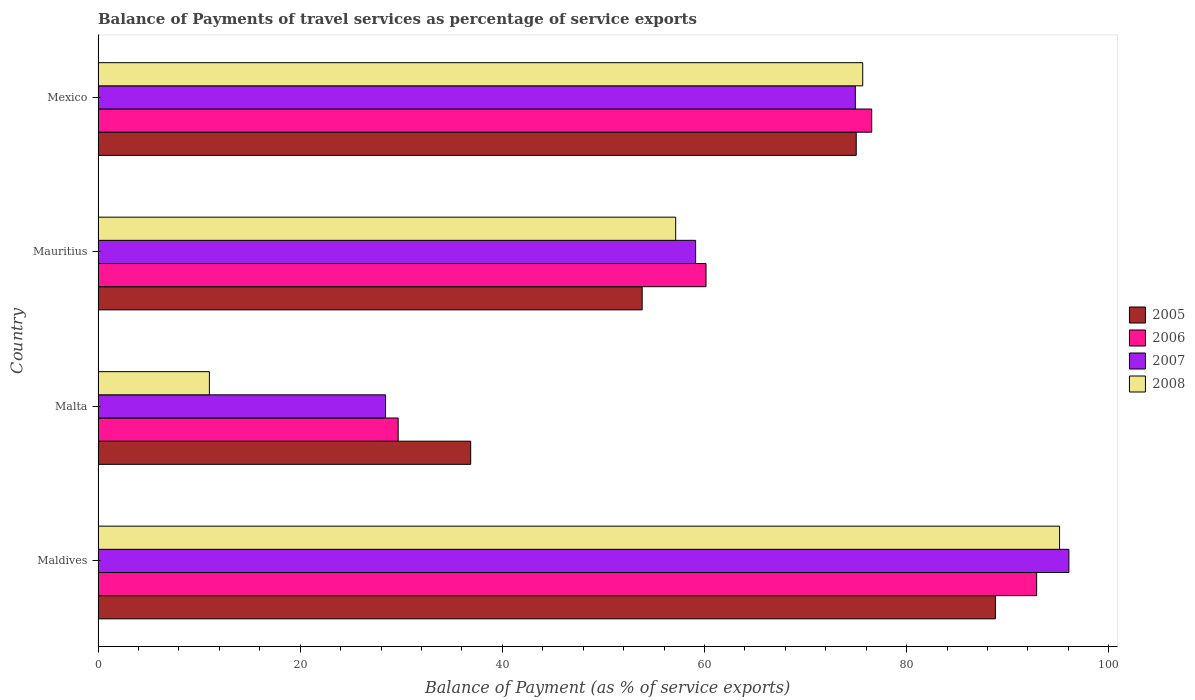How many different coloured bars are there?
Provide a succinct answer. 4. How many groups of bars are there?
Give a very brief answer. 4. Are the number of bars on each tick of the Y-axis equal?
Offer a terse response. Yes. How many bars are there on the 2nd tick from the bottom?
Offer a very short reply. 4. What is the label of the 4th group of bars from the top?
Offer a very short reply. Maldives. In how many cases, is the number of bars for a given country not equal to the number of legend labels?
Offer a very short reply. 0. What is the balance of payments of travel services in 2005 in Malta?
Make the answer very short. 36.87. Across all countries, what is the maximum balance of payments of travel services in 2007?
Offer a terse response. 96.05. Across all countries, what is the minimum balance of payments of travel services in 2005?
Offer a very short reply. 36.87. In which country was the balance of payments of travel services in 2005 maximum?
Ensure brevity in your answer.  Maldives. In which country was the balance of payments of travel services in 2007 minimum?
Make the answer very short. Malta. What is the total balance of payments of travel services in 2006 in the graph?
Your answer should be compact. 259.24. What is the difference between the balance of payments of travel services in 2006 in Maldives and that in Mauritius?
Ensure brevity in your answer.  32.71. What is the difference between the balance of payments of travel services in 2008 in Mauritius and the balance of payments of travel services in 2006 in Malta?
Give a very brief answer. 27.46. What is the average balance of payments of travel services in 2008 per country?
Offer a terse response. 59.73. What is the difference between the balance of payments of travel services in 2007 and balance of payments of travel services in 2005 in Mauritius?
Ensure brevity in your answer.  5.29. What is the ratio of the balance of payments of travel services in 2008 in Malta to that in Mauritius?
Keep it short and to the point. 0.19. Is the balance of payments of travel services in 2007 in Maldives less than that in Mauritius?
Provide a succinct answer. No. What is the difference between the highest and the second highest balance of payments of travel services in 2005?
Your response must be concise. 13.77. What is the difference between the highest and the lowest balance of payments of travel services in 2005?
Ensure brevity in your answer.  51.91. In how many countries, is the balance of payments of travel services in 2007 greater than the average balance of payments of travel services in 2007 taken over all countries?
Provide a short and direct response. 2. Is the sum of the balance of payments of travel services in 2006 in Malta and Mexico greater than the maximum balance of payments of travel services in 2005 across all countries?
Offer a terse response. Yes. Is it the case that in every country, the sum of the balance of payments of travel services in 2006 and balance of payments of travel services in 2005 is greater than the sum of balance of payments of travel services in 2007 and balance of payments of travel services in 2008?
Provide a short and direct response. No. What does the 3rd bar from the top in Malta represents?
Offer a very short reply. 2006. What does the 4th bar from the bottom in Mauritius represents?
Give a very brief answer. 2008. Is it the case that in every country, the sum of the balance of payments of travel services in 2007 and balance of payments of travel services in 2008 is greater than the balance of payments of travel services in 2005?
Provide a succinct answer. Yes. Are all the bars in the graph horizontal?
Make the answer very short. Yes. Are the values on the major ticks of X-axis written in scientific E-notation?
Keep it short and to the point. No. Does the graph contain any zero values?
Offer a very short reply. No. Does the graph contain grids?
Provide a short and direct response. No. Where does the legend appear in the graph?
Provide a short and direct response. Center right. How many legend labels are there?
Give a very brief answer. 4. How are the legend labels stacked?
Make the answer very short. Vertical. What is the title of the graph?
Your answer should be very brief. Balance of Payments of travel services as percentage of service exports. What is the label or title of the X-axis?
Provide a short and direct response. Balance of Payment (as % of service exports). What is the Balance of Payment (as % of service exports) in 2005 in Maldives?
Offer a very short reply. 88.78. What is the Balance of Payment (as % of service exports) of 2006 in Maldives?
Your response must be concise. 92.86. What is the Balance of Payment (as % of service exports) of 2007 in Maldives?
Your answer should be very brief. 96.05. What is the Balance of Payment (as % of service exports) in 2008 in Maldives?
Your answer should be compact. 95.13. What is the Balance of Payment (as % of service exports) of 2005 in Malta?
Your answer should be very brief. 36.87. What is the Balance of Payment (as % of service exports) of 2006 in Malta?
Your answer should be very brief. 29.69. What is the Balance of Payment (as % of service exports) of 2007 in Malta?
Give a very brief answer. 28.44. What is the Balance of Payment (as % of service exports) of 2008 in Malta?
Offer a very short reply. 11.02. What is the Balance of Payment (as % of service exports) of 2005 in Mauritius?
Make the answer very short. 53.83. What is the Balance of Payment (as % of service exports) of 2006 in Mauritius?
Ensure brevity in your answer.  60.15. What is the Balance of Payment (as % of service exports) of 2007 in Mauritius?
Offer a terse response. 59.12. What is the Balance of Payment (as % of service exports) of 2008 in Mauritius?
Keep it short and to the point. 57.15. What is the Balance of Payment (as % of service exports) of 2005 in Mexico?
Make the answer very short. 75.01. What is the Balance of Payment (as % of service exports) of 2006 in Mexico?
Make the answer very short. 76.54. What is the Balance of Payment (as % of service exports) of 2007 in Mexico?
Make the answer very short. 74.92. What is the Balance of Payment (as % of service exports) in 2008 in Mexico?
Ensure brevity in your answer.  75.65. Across all countries, what is the maximum Balance of Payment (as % of service exports) of 2005?
Your answer should be compact. 88.78. Across all countries, what is the maximum Balance of Payment (as % of service exports) in 2006?
Keep it short and to the point. 92.86. Across all countries, what is the maximum Balance of Payment (as % of service exports) of 2007?
Offer a very short reply. 96.05. Across all countries, what is the maximum Balance of Payment (as % of service exports) of 2008?
Keep it short and to the point. 95.13. Across all countries, what is the minimum Balance of Payment (as % of service exports) in 2005?
Keep it short and to the point. 36.87. Across all countries, what is the minimum Balance of Payment (as % of service exports) in 2006?
Offer a terse response. 29.69. Across all countries, what is the minimum Balance of Payment (as % of service exports) of 2007?
Offer a very short reply. 28.44. Across all countries, what is the minimum Balance of Payment (as % of service exports) in 2008?
Your response must be concise. 11.02. What is the total Balance of Payment (as % of service exports) in 2005 in the graph?
Keep it short and to the point. 254.48. What is the total Balance of Payment (as % of service exports) in 2006 in the graph?
Keep it short and to the point. 259.24. What is the total Balance of Payment (as % of service exports) in 2007 in the graph?
Provide a short and direct response. 258.53. What is the total Balance of Payment (as % of service exports) of 2008 in the graph?
Make the answer very short. 238.94. What is the difference between the Balance of Payment (as % of service exports) in 2005 in Maldives and that in Malta?
Make the answer very short. 51.91. What is the difference between the Balance of Payment (as % of service exports) of 2006 in Maldives and that in Malta?
Give a very brief answer. 63.17. What is the difference between the Balance of Payment (as % of service exports) of 2007 in Maldives and that in Malta?
Ensure brevity in your answer.  67.61. What is the difference between the Balance of Payment (as % of service exports) in 2008 in Maldives and that in Malta?
Your response must be concise. 84.11. What is the difference between the Balance of Payment (as % of service exports) in 2005 in Maldives and that in Mauritius?
Provide a succinct answer. 34.95. What is the difference between the Balance of Payment (as % of service exports) in 2006 in Maldives and that in Mauritius?
Offer a very short reply. 32.71. What is the difference between the Balance of Payment (as % of service exports) of 2007 in Maldives and that in Mauritius?
Provide a succinct answer. 36.93. What is the difference between the Balance of Payment (as % of service exports) of 2008 in Maldives and that in Mauritius?
Offer a very short reply. 37.98. What is the difference between the Balance of Payment (as % of service exports) of 2005 in Maldives and that in Mexico?
Offer a terse response. 13.77. What is the difference between the Balance of Payment (as % of service exports) in 2006 in Maldives and that in Mexico?
Provide a succinct answer. 16.32. What is the difference between the Balance of Payment (as % of service exports) of 2007 in Maldives and that in Mexico?
Provide a short and direct response. 21.13. What is the difference between the Balance of Payment (as % of service exports) of 2008 in Maldives and that in Mexico?
Keep it short and to the point. 19.47. What is the difference between the Balance of Payment (as % of service exports) of 2005 in Malta and that in Mauritius?
Ensure brevity in your answer.  -16.96. What is the difference between the Balance of Payment (as % of service exports) in 2006 in Malta and that in Mauritius?
Your answer should be compact. -30.46. What is the difference between the Balance of Payment (as % of service exports) of 2007 in Malta and that in Mauritius?
Provide a short and direct response. -30.68. What is the difference between the Balance of Payment (as % of service exports) of 2008 in Malta and that in Mauritius?
Offer a terse response. -46.13. What is the difference between the Balance of Payment (as % of service exports) of 2005 in Malta and that in Mexico?
Your answer should be compact. -38.14. What is the difference between the Balance of Payment (as % of service exports) in 2006 in Malta and that in Mexico?
Keep it short and to the point. -46.85. What is the difference between the Balance of Payment (as % of service exports) of 2007 in Malta and that in Mexico?
Ensure brevity in your answer.  -46.48. What is the difference between the Balance of Payment (as % of service exports) of 2008 in Malta and that in Mexico?
Your answer should be very brief. -64.64. What is the difference between the Balance of Payment (as % of service exports) in 2005 in Mauritius and that in Mexico?
Ensure brevity in your answer.  -21.18. What is the difference between the Balance of Payment (as % of service exports) of 2006 in Mauritius and that in Mexico?
Make the answer very short. -16.39. What is the difference between the Balance of Payment (as % of service exports) in 2007 in Mauritius and that in Mexico?
Provide a short and direct response. -15.8. What is the difference between the Balance of Payment (as % of service exports) of 2008 in Mauritius and that in Mexico?
Keep it short and to the point. -18.5. What is the difference between the Balance of Payment (as % of service exports) in 2005 in Maldives and the Balance of Payment (as % of service exports) in 2006 in Malta?
Your response must be concise. 59.09. What is the difference between the Balance of Payment (as % of service exports) in 2005 in Maldives and the Balance of Payment (as % of service exports) in 2007 in Malta?
Offer a terse response. 60.34. What is the difference between the Balance of Payment (as % of service exports) of 2005 in Maldives and the Balance of Payment (as % of service exports) of 2008 in Malta?
Make the answer very short. 77.76. What is the difference between the Balance of Payment (as % of service exports) in 2006 in Maldives and the Balance of Payment (as % of service exports) in 2007 in Malta?
Provide a succinct answer. 64.42. What is the difference between the Balance of Payment (as % of service exports) in 2006 in Maldives and the Balance of Payment (as % of service exports) in 2008 in Malta?
Ensure brevity in your answer.  81.84. What is the difference between the Balance of Payment (as % of service exports) of 2007 in Maldives and the Balance of Payment (as % of service exports) of 2008 in Malta?
Provide a succinct answer. 85.03. What is the difference between the Balance of Payment (as % of service exports) in 2005 in Maldives and the Balance of Payment (as % of service exports) in 2006 in Mauritius?
Offer a terse response. 28.63. What is the difference between the Balance of Payment (as % of service exports) of 2005 in Maldives and the Balance of Payment (as % of service exports) of 2007 in Mauritius?
Your response must be concise. 29.66. What is the difference between the Balance of Payment (as % of service exports) of 2005 in Maldives and the Balance of Payment (as % of service exports) of 2008 in Mauritius?
Keep it short and to the point. 31.63. What is the difference between the Balance of Payment (as % of service exports) of 2006 in Maldives and the Balance of Payment (as % of service exports) of 2007 in Mauritius?
Your answer should be very brief. 33.74. What is the difference between the Balance of Payment (as % of service exports) of 2006 in Maldives and the Balance of Payment (as % of service exports) of 2008 in Mauritius?
Offer a very short reply. 35.71. What is the difference between the Balance of Payment (as % of service exports) in 2007 in Maldives and the Balance of Payment (as % of service exports) in 2008 in Mauritius?
Your answer should be very brief. 38.9. What is the difference between the Balance of Payment (as % of service exports) of 2005 in Maldives and the Balance of Payment (as % of service exports) of 2006 in Mexico?
Give a very brief answer. 12.24. What is the difference between the Balance of Payment (as % of service exports) in 2005 in Maldives and the Balance of Payment (as % of service exports) in 2007 in Mexico?
Offer a terse response. 13.86. What is the difference between the Balance of Payment (as % of service exports) of 2005 in Maldives and the Balance of Payment (as % of service exports) of 2008 in Mexico?
Provide a short and direct response. 13.12. What is the difference between the Balance of Payment (as % of service exports) in 2006 in Maldives and the Balance of Payment (as % of service exports) in 2007 in Mexico?
Make the answer very short. 17.94. What is the difference between the Balance of Payment (as % of service exports) in 2006 in Maldives and the Balance of Payment (as % of service exports) in 2008 in Mexico?
Offer a very short reply. 17.21. What is the difference between the Balance of Payment (as % of service exports) in 2007 in Maldives and the Balance of Payment (as % of service exports) in 2008 in Mexico?
Your answer should be very brief. 20.4. What is the difference between the Balance of Payment (as % of service exports) in 2005 in Malta and the Balance of Payment (as % of service exports) in 2006 in Mauritius?
Keep it short and to the point. -23.28. What is the difference between the Balance of Payment (as % of service exports) in 2005 in Malta and the Balance of Payment (as % of service exports) in 2007 in Mauritius?
Your answer should be very brief. -22.25. What is the difference between the Balance of Payment (as % of service exports) in 2005 in Malta and the Balance of Payment (as % of service exports) in 2008 in Mauritius?
Ensure brevity in your answer.  -20.28. What is the difference between the Balance of Payment (as % of service exports) in 2006 in Malta and the Balance of Payment (as % of service exports) in 2007 in Mauritius?
Offer a terse response. -29.43. What is the difference between the Balance of Payment (as % of service exports) in 2006 in Malta and the Balance of Payment (as % of service exports) in 2008 in Mauritius?
Give a very brief answer. -27.46. What is the difference between the Balance of Payment (as % of service exports) of 2007 in Malta and the Balance of Payment (as % of service exports) of 2008 in Mauritius?
Ensure brevity in your answer.  -28.71. What is the difference between the Balance of Payment (as % of service exports) of 2005 in Malta and the Balance of Payment (as % of service exports) of 2006 in Mexico?
Make the answer very short. -39.67. What is the difference between the Balance of Payment (as % of service exports) in 2005 in Malta and the Balance of Payment (as % of service exports) in 2007 in Mexico?
Provide a short and direct response. -38.05. What is the difference between the Balance of Payment (as % of service exports) in 2005 in Malta and the Balance of Payment (as % of service exports) in 2008 in Mexico?
Provide a short and direct response. -38.78. What is the difference between the Balance of Payment (as % of service exports) of 2006 in Malta and the Balance of Payment (as % of service exports) of 2007 in Mexico?
Your response must be concise. -45.23. What is the difference between the Balance of Payment (as % of service exports) in 2006 in Malta and the Balance of Payment (as % of service exports) in 2008 in Mexico?
Keep it short and to the point. -45.96. What is the difference between the Balance of Payment (as % of service exports) in 2007 in Malta and the Balance of Payment (as % of service exports) in 2008 in Mexico?
Keep it short and to the point. -47.21. What is the difference between the Balance of Payment (as % of service exports) of 2005 in Mauritius and the Balance of Payment (as % of service exports) of 2006 in Mexico?
Provide a succinct answer. -22.71. What is the difference between the Balance of Payment (as % of service exports) in 2005 in Mauritius and the Balance of Payment (as % of service exports) in 2007 in Mexico?
Offer a terse response. -21.09. What is the difference between the Balance of Payment (as % of service exports) in 2005 in Mauritius and the Balance of Payment (as % of service exports) in 2008 in Mexico?
Ensure brevity in your answer.  -21.82. What is the difference between the Balance of Payment (as % of service exports) of 2006 in Mauritius and the Balance of Payment (as % of service exports) of 2007 in Mexico?
Provide a short and direct response. -14.77. What is the difference between the Balance of Payment (as % of service exports) in 2006 in Mauritius and the Balance of Payment (as % of service exports) in 2008 in Mexico?
Keep it short and to the point. -15.5. What is the difference between the Balance of Payment (as % of service exports) of 2007 in Mauritius and the Balance of Payment (as % of service exports) of 2008 in Mexico?
Your answer should be very brief. -16.53. What is the average Balance of Payment (as % of service exports) of 2005 per country?
Keep it short and to the point. 63.62. What is the average Balance of Payment (as % of service exports) in 2006 per country?
Make the answer very short. 64.81. What is the average Balance of Payment (as % of service exports) of 2007 per country?
Provide a short and direct response. 64.63. What is the average Balance of Payment (as % of service exports) of 2008 per country?
Make the answer very short. 59.73. What is the difference between the Balance of Payment (as % of service exports) in 2005 and Balance of Payment (as % of service exports) in 2006 in Maldives?
Your answer should be very brief. -4.08. What is the difference between the Balance of Payment (as % of service exports) in 2005 and Balance of Payment (as % of service exports) in 2007 in Maldives?
Your answer should be very brief. -7.27. What is the difference between the Balance of Payment (as % of service exports) in 2005 and Balance of Payment (as % of service exports) in 2008 in Maldives?
Ensure brevity in your answer.  -6.35. What is the difference between the Balance of Payment (as % of service exports) in 2006 and Balance of Payment (as % of service exports) in 2007 in Maldives?
Give a very brief answer. -3.19. What is the difference between the Balance of Payment (as % of service exports) of 2006 and Balance of Payment (as % of service exports) of 2008 in Maldives?
Your answer should be compact. -2.27. What is the difference between the Balance of Payment (as % of service exports) in 2007 and Balance of Payment (as % of service exports) in 2008 in Maldives?
Give a very brief answer. 0.92. What is the difference between the Balance of Payment (as % of service exports) of 2005 and Balance of Payment (as % of service exports) of 2006 in Malta?
Provide a short and direct response. 7.18. What is the difference between the Balance of Payment (as % of service exports) in 2005 and Balance of Payment (as % of service exports) in 2007 in Malta?
Keep it short and to the point. 8.43. What is the difference between the Balance of Payment (as % of service exports) of 2005 and Balance of Payment (as % of service exports) of 2008 in Malta?
Give a very brief answer. 25.85. What is the difference between the Balance of Payment (as % of service exports) in 2006 and Balance of Payment (as % of service exports) in 2007 in Malta?
Your answer should be compact. 1.25. What is the difference between the Balance of Payment (as % of service exports) of 2006 and Balance of Payment (as % of service exports) of 2008 in Malta?
Provide a short and direct response. 18.67. What is the difference between the Balance of Payment (as % of service exports) of 2007 and Balance of Payment (as % of service exports) of 2008 in Malta?
Your answer should be compact. 17.43. What is the difference between the Balance of Payment (as % of service exports) in 2005 and Balance of Payment (as % of service exports) in 2006 in Mauritius?
Your answer should be compact. -6.32. What is the difference between the Balance of Payment (as % of service exports) of 2005 and Balance of Payment (as % of service exports) of 2007 in Mauritius?
Your answer should be compact. -5.29. What is the difference between the Balance of Payment (as % of service exports) in 2005 and Balance of Payment (as % of service exports) in 2008 in Mauritius?
Give a very brief answer. -3.32. What is the difference between the Balance of Payment (as % of service exports) in 2006 and Balance of Payment (as % of service exports) in 2007 in Mauritius?
Ensure brevity in your answer.  1.03. What is the difference between the Balance of Payment (as % of service exports) of 2006 and Balance of Payment (as % of service exports) of 2008 in Mauritius?
Your answer should be very brief. 3. What is the difference between the Balance of Payment (as % of service exports) in 2007 and Balance of Payment (as % of service exports) in 2008 in Mauritius?
Give a very brief answer. 1.97. What is the difference between the Balance of Payment (as % of service exports) of 2005 and Balance of Payment (as % of service exports) of 2006 in Mexico?
Provide a succinct answer. -1.53. What is the difference between the Balance of Payment (as % of service exports) in 2005 and Balance of Payment (as % of service exports) in 2007 in Mexico?
Ensure brevity in your answer.  0.09. What is the difference between the Balance of Payment (as % of service exports) of 2005 and Balance of Payment (as % of service exports) of 2008 in Mexico?
Provide a succinct answer. -0.64. What is the difference between the Balance of Payment (as % of service exports) in 2006 and Balance of Payment (as % of service exports) in 2007 in Mexico?
Your answer should be very brief. 1.62. What is the difference between the Balance of Payment (as % of service exports) in 2006 and Balance of Payment (as % of service exports) in 2008 in Mexico?
Your answer should be compact. 0.89. What is the difference between the Balance of Payment (as % of service exports) of 2007 and Balance of Payment (as % of service exports) of 2008 in Mexico?
Make the answer very short. -0.73. What is the ratio of the Balance of Payment (as % of service exports) in 2005 in Maldives to that in Malta?
Ensure brevity in your answer.  2.41. What is the ratio of the Balance of Payment (as % of service exports) in 2006 in Maldives to that in Malta?
Offer a terse response. 3.13. What is the ratio of the Balance of Payment (as % of service exports) of 2007 in Maldives to that in Malta?
Keep it short and to the point. 3.38. What is the ratio of the Balance of Payment (as % of service exports) of 2008 in Maldives to that in Malta?
Keep it short and to the point. 8.64. What is the ratio of the Balance of Payment (as % of service exports) of 2005 in Maldives to that in Mauritius?
Provide a succinct answer. 1.65. What is the ratio of the Balance of Payment (as % of service exports) in 2006 in Maldives to that in Mauritius?
Provide a short and direct response. 1.54. What is the ratio of the Balance of Payment (as % of service exports) in 2007 in Maldives to that in Mauritius?
Your response must be concise. 1.62. What is the ratio of the Balance of Payment (as % of service exports) in 2008 in Maldives to that in Mauritius?
Your response must be concise. 1.66. What is the ratio of the Balance of Payment (as % of service exports) in 2005 in Maldives to that in Mexico?
Your response must be concise. 1.18. What is the ratio of the Balance of Payment (as % of service exports) of 2006 in Maldives to that in Mexico?
Keep it short and to the point. 1.21. What is the ratio of the Balance of Payment (as % of service exports) of 2007 in Maldives to that in Mexico?
Offer a very short reply. 1.28. What is the ratio of the Balance of Payment (as % of service exports) of 2008 in Maldives to that in Mexico?
Offer a terse response. 1.26. What is the ratio of the Balance of Payment (as % of service exports) of 2005 in Malta to that in Mauritius?
Make the answer very short. 0.68. What is the ratio of the Balance of Payment (as % of service exports) in 2006 in Malta to that in Mauritius?
Your answer should be compact. 0.49. What is the ratio of the Balance of Payment (as % of service exports) of 2007 in Malta to that in Mauritius?
Keep it short and to the point. 0.48. What is the ratio of the Balance of Payment (as % of service exports) of 2008 in Malta to that in Mauritius?
Ensure brevity in your answer.  0.19. What is the ratio of the Balance of Payment (as % of service exports) of 2005 in Malta to that in Mexico?
Offer a very short reply. 0.49. What is the ratio of the Balance of Payment (as % of service exports) in 2006 in Malta to that in Mexico?
Your response must be concise. 0.39. What is the ratio of the Balance of Payment (as % of service exports) in 2007 in Malta to that in Mexico?
Provide a succinct answer. 0.38. What is the ratio of the Balance of Payment (as % of service exports) in 2008 in Malta to that in Mexico?
Your answer should be compact. 0.15. What is the ratio of the Balance of Payment (as % of service exports) of 2005 in Mauritius to that in Mexico?
Ensure brevity in your answer.  0.72. What is the ratio of the Balance of Payment (as % of service exports) of 2006 in Mauritius to that in Mexico?
Provide a short and direct response. 0.79. What is the ratio of the Balance of Payment (as % of service exports) in 2007 in Mauritius to that in Mexico?
Your response must be concise. 0.79. What is the ratio of the Balance of Payment (as % of service exports) of 2008 in Mauritius to that in Mexico?
Provide a succinct answer. 0.76. What is the difference between the highest and the second highest Balance of Payment (as % of service exports) of 2005?
Your answer should be very brief. 13.77. What is the difference between the highest and the second highest Balance of Payment (as % of service exports) of 2006?
Make the answer very short. 16.32. What is the difference between the highest and the second highest Balance of Payment (as % of service exports) of 2007?
Your response must be concise. 21.13. What is the difference between the highest and the second highest Balance of Payment (as % of service exports) of 2008?
Ensure brevity in your answer.  19.47. What is the difference between the highest and the lowest Balance of Payment (as % of service exports) in 2005?
Offer a very short reply. 51.91. What is the difference between the highest and the lowest Balance of Payment (as % of service exports) in 2006?
Your response must be concise. 63.17. What is the difference between the highest and the lowest Balance of Payment (as % of service exports) of 2007?
Keep it short and to the point. 67.61. What is the difference between the highest and the lowest Balance of Payment (as % of service exports) in 2008?
Your answer should be very brief. 84.11. 